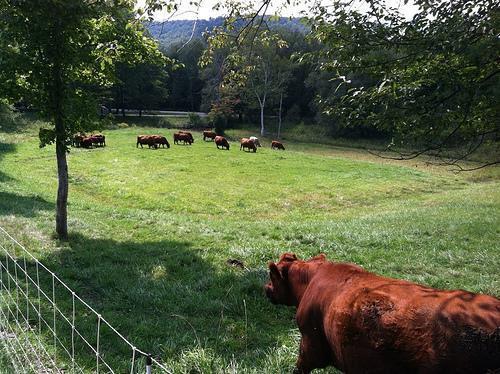How many white cows can be seen here?
Give a very brief answer. 1. How many people appear in this picture?
Give a very brief answer. 0. How many cows are not heads down eating grass?
Give a very brief answer. 1. How many of the cows are standing next to the wire fence?
Give a very brief answer. 1. 